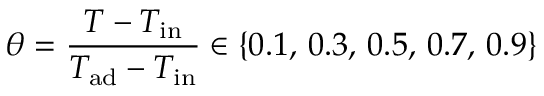Convert formula to latex. <formula><loc_0><loc_0><loc_500><loc_500>\theta = \frac { T - T _ { i n } } { T _ { a d } - T _ { i n } } \in \{ 0 . 1 , \, 0 . 3 , \, 0 . 5 , \, 0 . 7 , \, 0 . 9 \}</formula> 